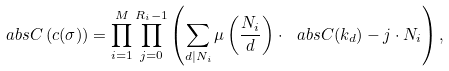Convert formula to latex. <formula><loc_0><loc_0><loc_500><loc_500>\ a b s { C \left ( c ( \sigma ) \right ) } = \prod _ { i = 1 } ^ { M } \prod _ { j = 0 } ^ { R _ { i } - 1 } \left ( \sum _ { d | N _ { i } } \mu \left ( \frac { N _ { i } } { d } \right ) \cdot \ a b s { C ( k _ { d } ) } - j \cdot N _ { i } \right ) ,</formula> 